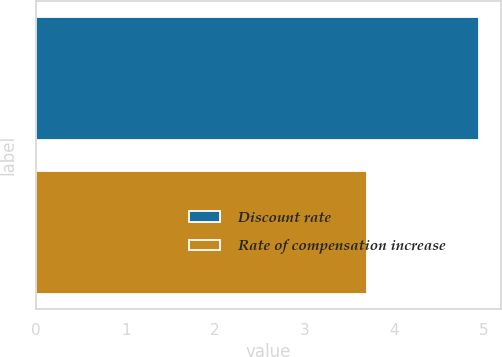<chart> <loc_0><loc_0><loc_500><loc_500><bar_chart><fcel>Discount rate<fcel>Rate of compensation increase<nl><fcel>4.95<fcel>3.7<nl></chart> 